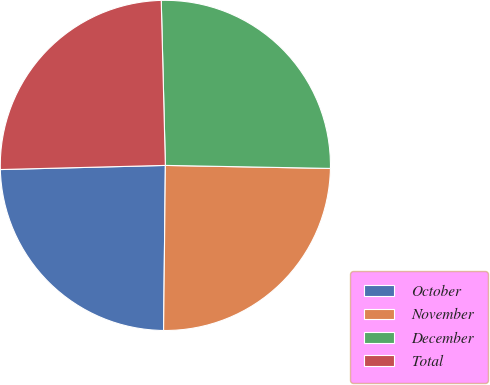<chart> <loc_0><loc_0><loc_500><loc_500><pie_chart><fcel>October<fcel>November<fcel>December<fcel>Total<nl><fcel>24.43%<fcel>24.88%<fcel>25.69%<fcel>25.0%<nl></chart> 